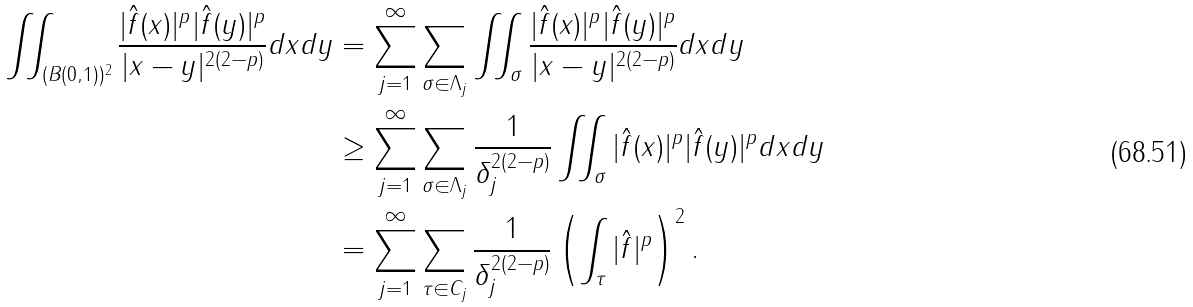Convert formula to latex. <formula><loc_0><loc_0><loc_500><loc_500>\iint _ { ( B ( 0 , 1 ) ) ^ { 2 } } \frac { | \hat { f } ( x ) | ^ { p } | \hat { f } ( y ) | ^ { p } } { | x - y | ^ { 2 ( 2 - p ) } } d x d y & = \sum _ { j = 1 } ^ { \infty } \sum _ { \sigma \in \Lambda _ { j } } \iint _ { \sigma } \frac { | \hat { f } ( x ) | ^ { p } | \hat { f } ( y ) | ^ { p } } { | x - y | ^ { 2 ( 2 - p ) } } d x d y \\ & \geq \sum _ { j = 1 } ^ { \infty } \sum _ { \sigma \in \Lambda _ { j } } \frac { 1 } { \delta _ { j } ^ { 2 ( 2 - p ) } } \iint _ { \sigma } | \hat { f } ( x ) | ^ { p } | \hat { f } ( y ) | ^ { p } d x d y \\ & = \sum _ { j = 1 } ^ { \infty } \sum _ { \tau \in C _ { j } } \frac { 1 } { \delta _ { j } ^ { 2 ( 2 - p ) } } \left ( \int _ { \tau } | \hat { f } | ^ { p } \right ) ^ { 2 } .</formula> 